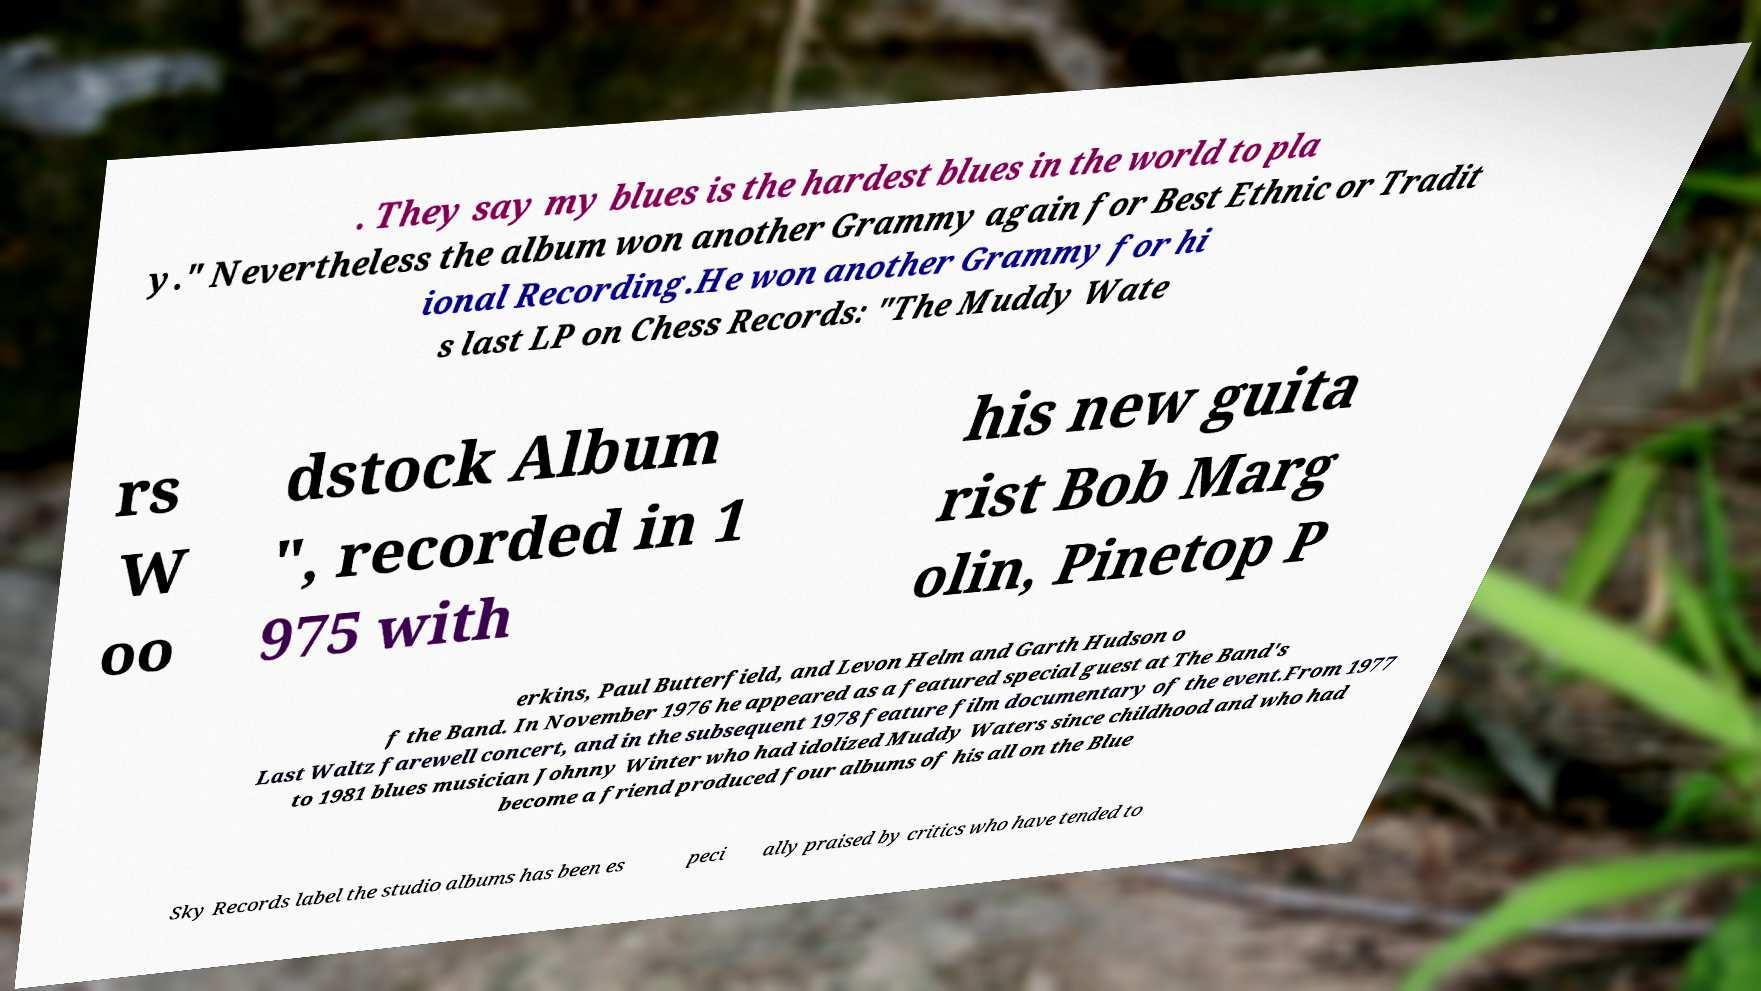Could you assist in decoding the text presented in this image and type it out clearly? . They say my blues is the hardest blues in the world to pla y." Nevertheless the album won another Grammy again for Best Ethnic or Tradit ional Recording.He won another Grammy for hi s last LP on Chess Records: "The Muddy Wate rs W oo dstock Album ", recorded in 1 975 with his new guita rist Bob Marg olin, Pinetop P erkins, Paul Butterfield, and Levon Helm and Garth Hudson o f the Band. In November 1976 he appeared as a featured special guest at The Band's Last Waltz farewell concert, and in the subsequent 1978 feature film documentary of the event.From 1977 to 1981 blues musician Johnny Winter who had idolized Muddy Waters since childhood and who had become a friend produced four albums of his all on the Blue Sky Records label the studio albums has been es peci ally praised by critics who have tended to 